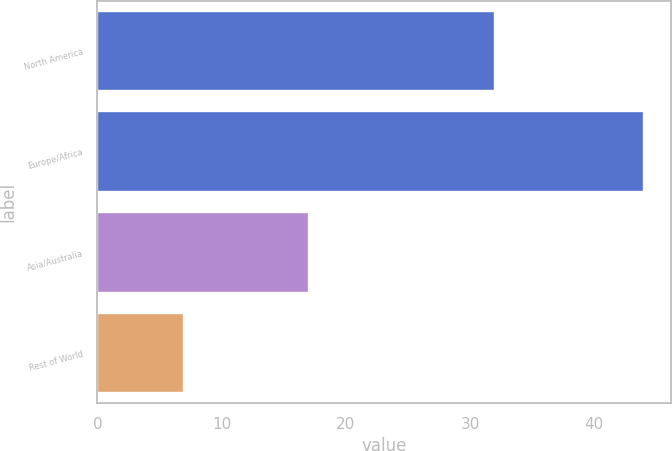Convert chart. <chart><loc_0><loc_0><loc_500><loc_500><bar_chart><fcel>North America<fcel>Europe/Africa<fcel>Asia/Australia<fcel>Rest of World<nl><fcel>32<fcel>44<fcel>17<fcel>7<nl></chart> 